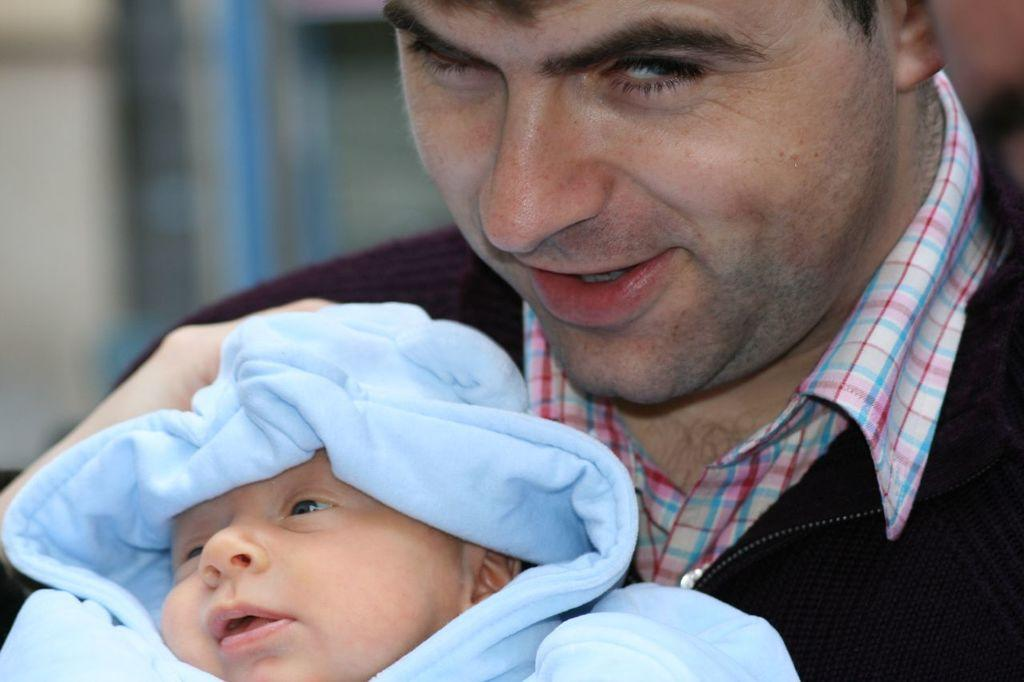What is the main subject of the image? There is a person in the image. What is the person in the image doing? The person is holding a baby. Where are the person and baby located in the image? The person and baby are in the center of the image. Is there any rain visible in the image? There is no rain present in the image. What type of glue is being used by the person in the image? There is no glue present in the image; the person is holding a baby. 